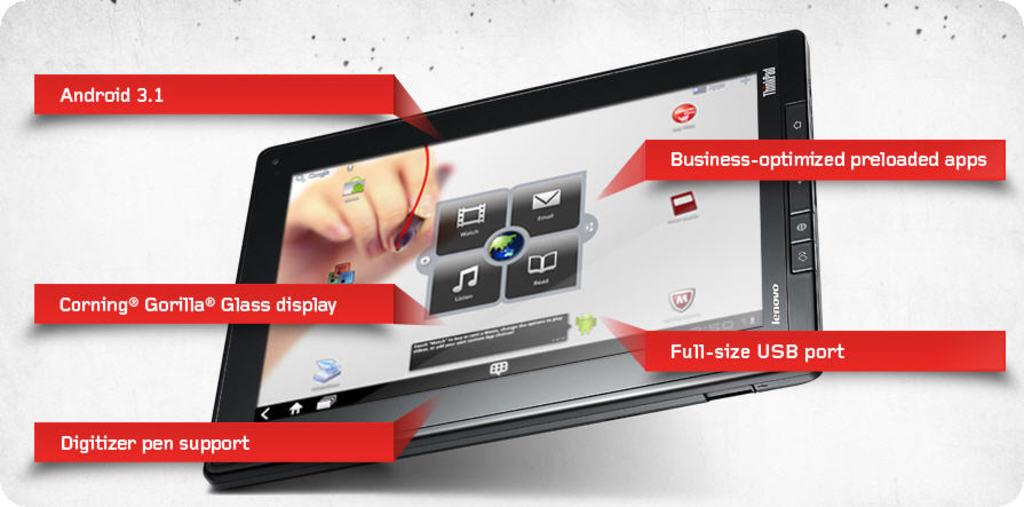What size usb port?
Provide a short and direct response. Full-size. 